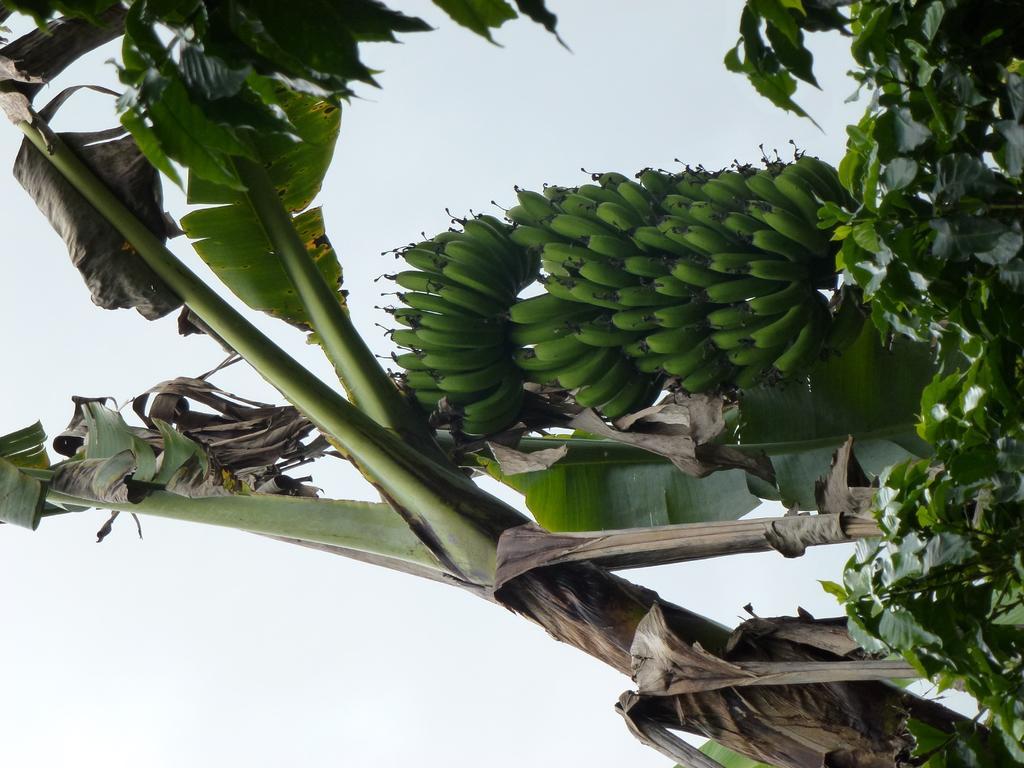Please provide a concise description of this image. In this image, we can see some bananas and there are some green leaves, we can see the sky. 